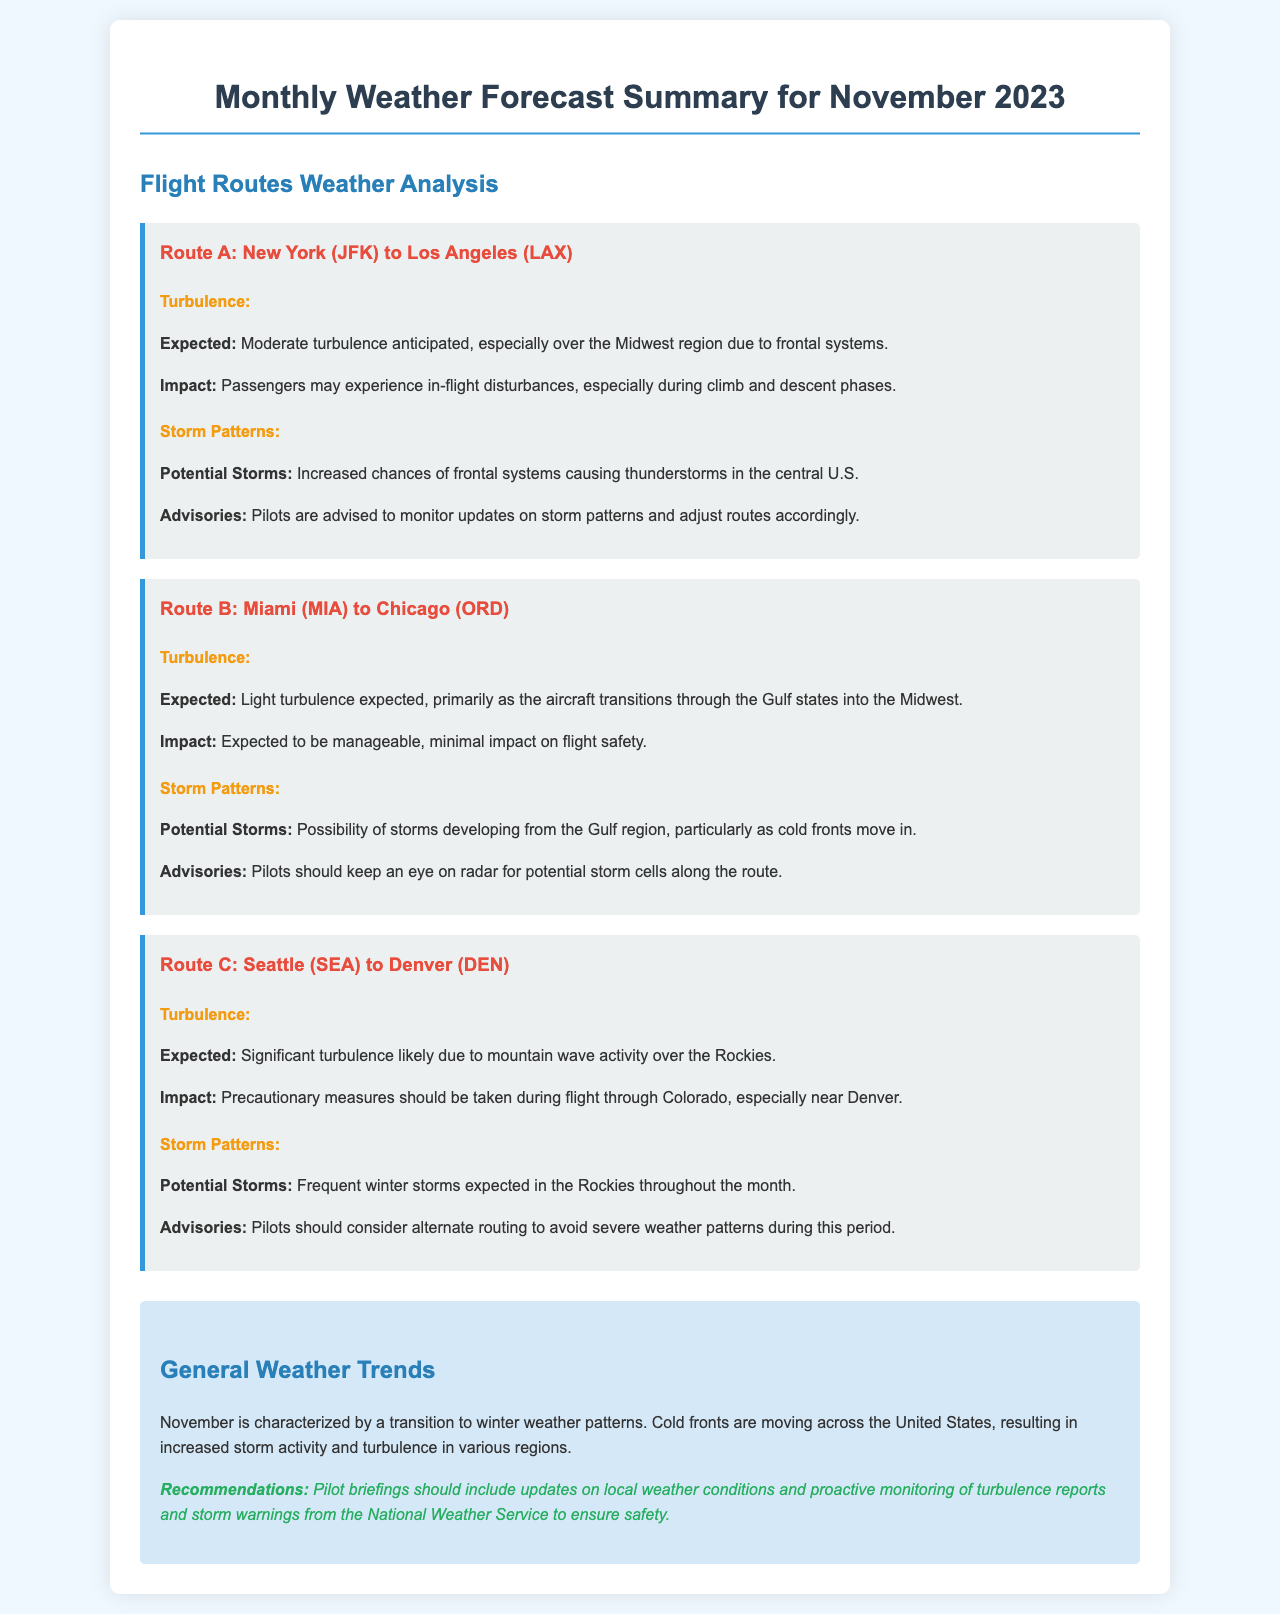What is the expected turbulence for Route A? The document states that moderate turbulence is anticipated, especially over the Midwest region due to frontal systems.
Answer: Moderate turbulence What is the expected turbulence for Route B? The expected turbulence for Route B is light, primarily during the transition through the Gulf states into the Midwest.
Answer: Light turbulence What potential storms are mentioned for Route C? The document mentions frequent winter storms expected in the Rockies throughout the month.
Answer: Frequent winter storms What advisory is recommended for Route A? Pilots are advised to monitor updates on storm patterns and adjust routes accordingly.
Answer: Monitor updates How should pilots prepare for Route C? The document advises that precautionary measures should be taken during flight through Colorado, especially near Denver.
Answer: Precautionary measures What is the main weather trend for November? November is characterized by a transition to winter weather patterns, with increased storm activity and turbulence.
Answer: Transition to winter What does the document recommend for pilot briefings? The recommendations include updates on local weather conditions and proactive monitoring of turbulence reports and storm warnings.
Answer: Updates on local weather conditions What is the impact of light turbulence during Route B? The expected impact from light turbulence is manageable and has minimal impact on flight safety.
Answer: Minimal impact on flight safety 